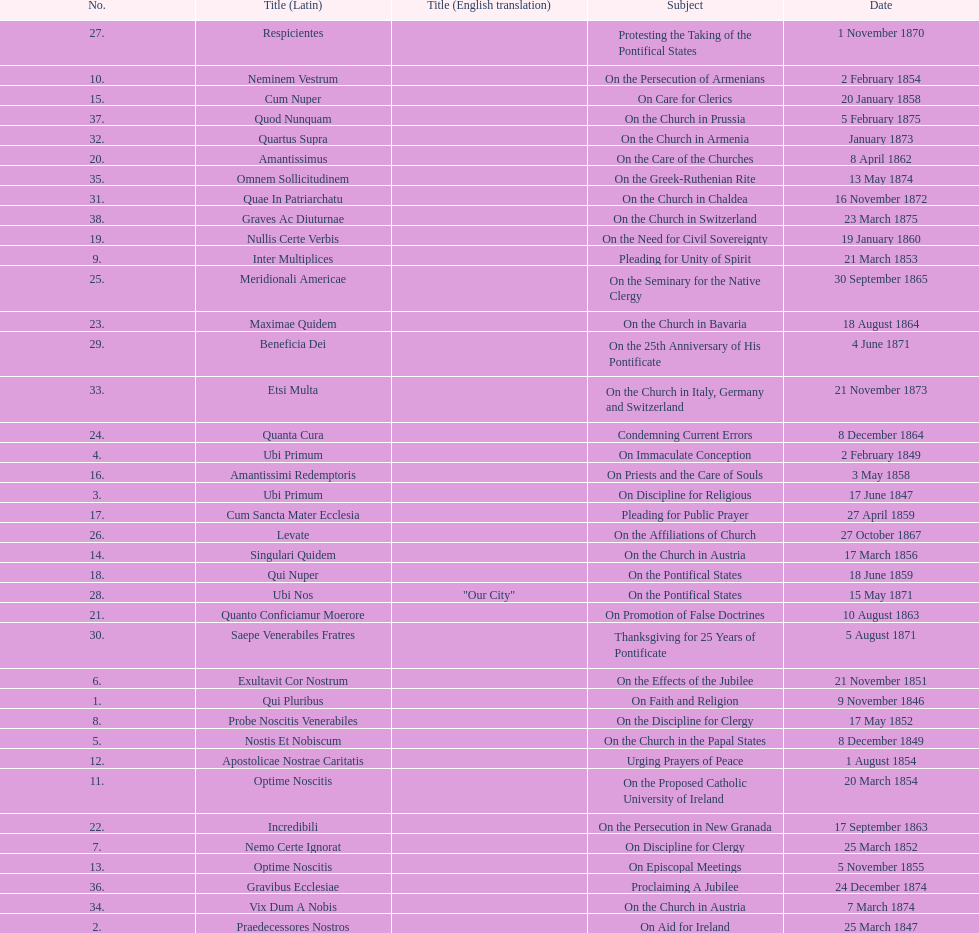Can you provide the latin name for the encyclical that came before the one addressing "on the church in bavaria"? Incredibili. 